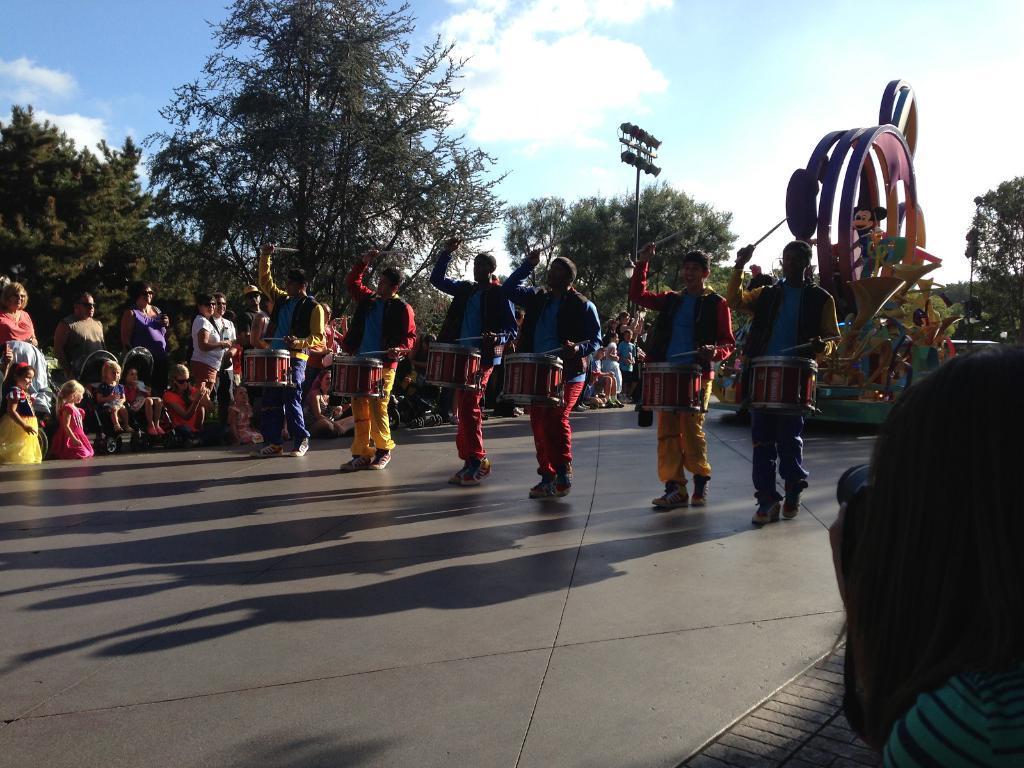Can you describe this image briefly? In the center of the image we can see people standing and playing drums. In the background there is crowd and we can see games and a pole. In the background there are trees and sky. 